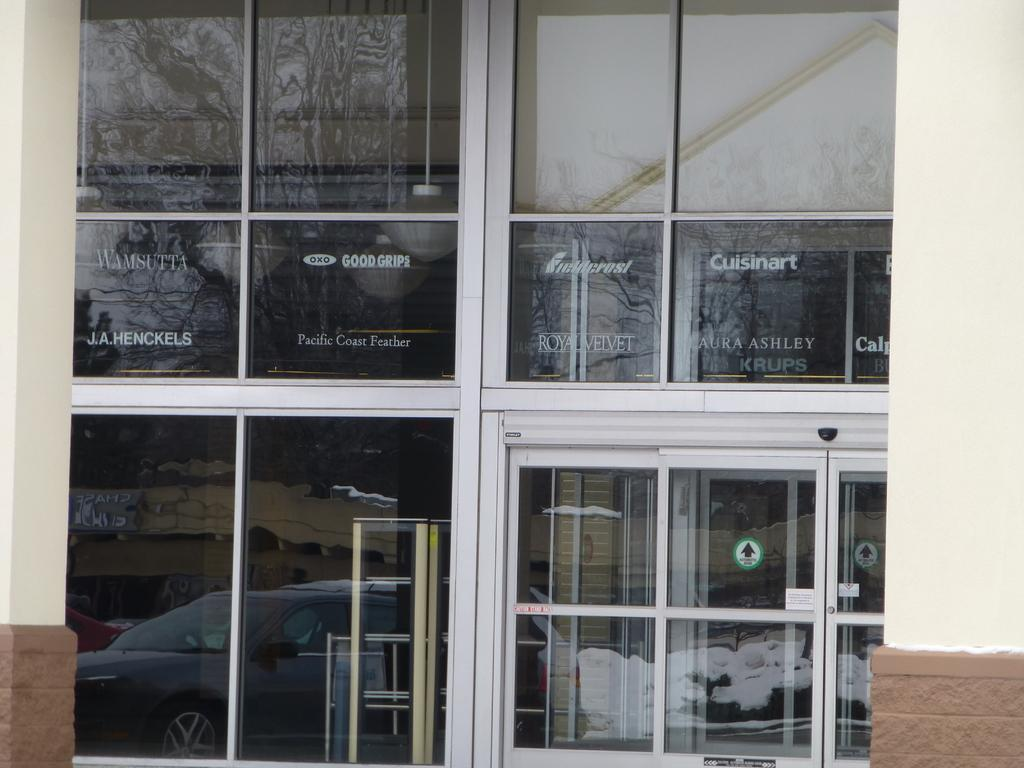What type of doors are visible in the image? There are glass doors in the image. What can be seen in the reflections on the glass doors? The glass doors have reflections of vehicles on the road and buildings. What type of connection can be seen between the glass doors and the bun in the image? There is no bun present in the image, and therefore no connection can be observed between the glass doors and a bun. 